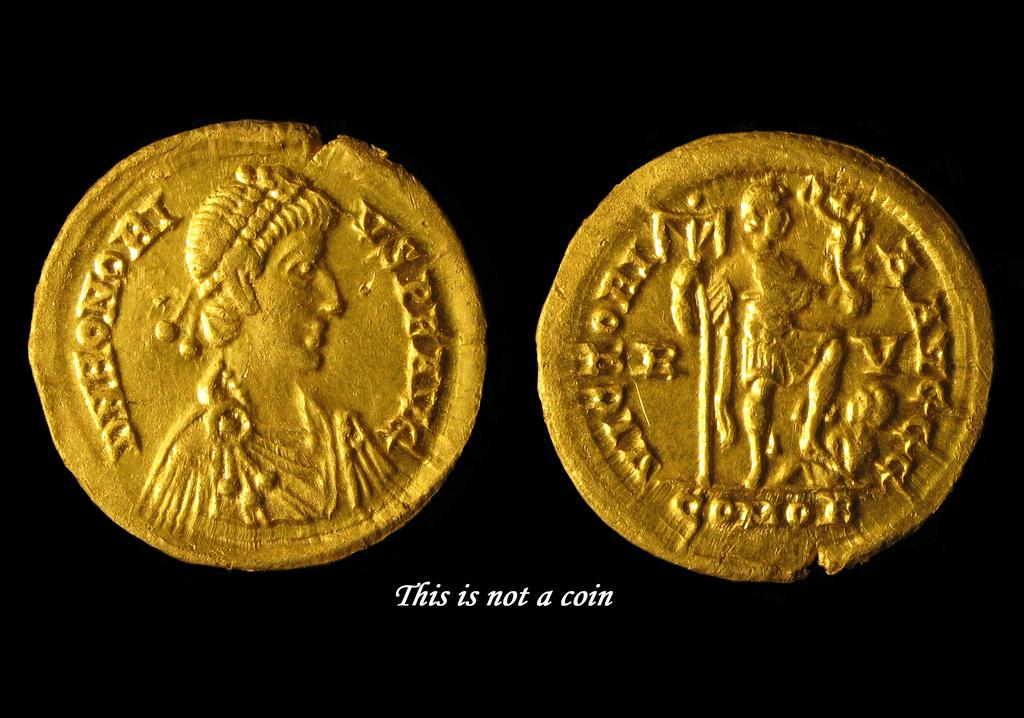How many coins are visible in the image? There are two coins in the image. What can be found on the surface of the coins? There is a symbol on the coins. What is written at the bottom of the image? There is text written at the bottom of the image. What is the color of the backdrop in the image? The backdrop of the image is dark. What is the name of the person attempting to answer the question in the image? There is no person or question present in the image; it only features two coins with a symbol and text. 